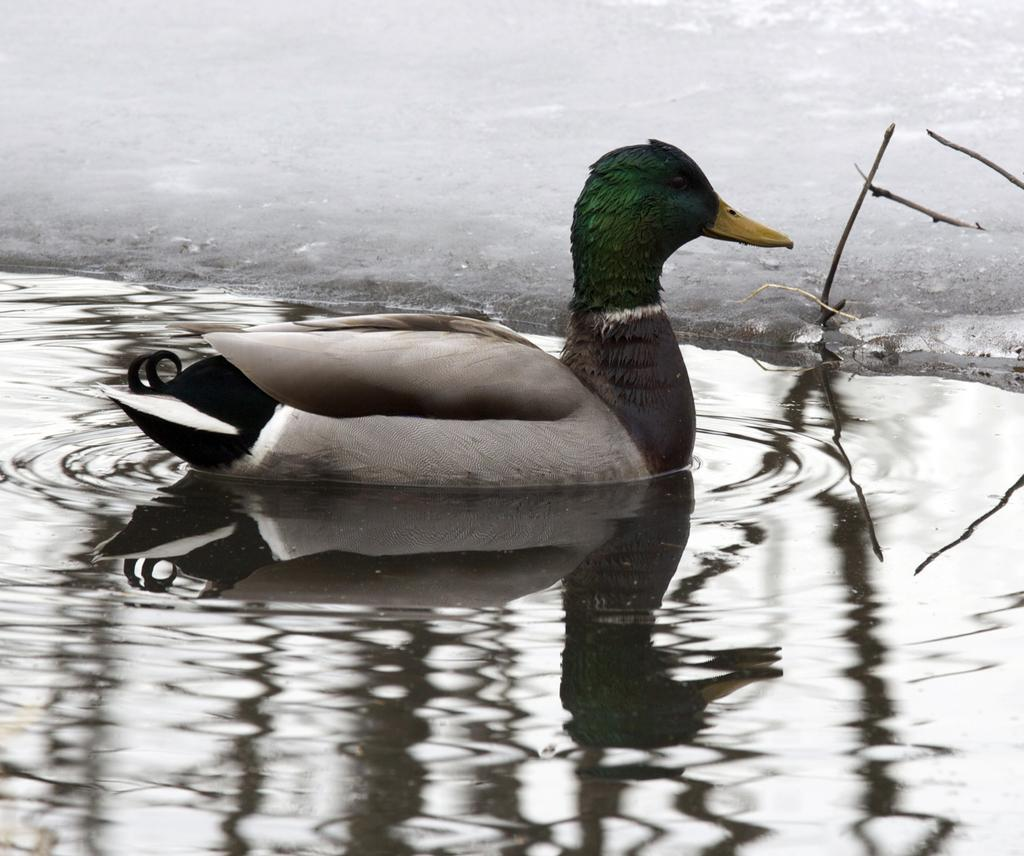What is the main subject in the center of the image? There is a duck in the center of the image. What is located at the bottom of the image? There is water at the bottom of the image. What is located at the top of the image? There is ground at the top of the image. What type of collar is the duck wearing in the image? There is no collar present on the duck in the image. How many trees can be seen in the image? There are no trees visible in the image; it only features a duck, water, and ground. 